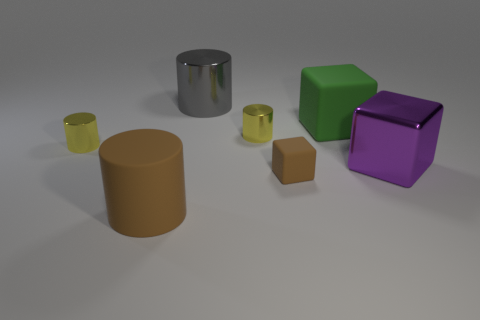Subtract all big metal blocks. How many blocks are left? 2 Add 1 yellow shiny objects. How many objects exist? 8 Subtract all purple blocks. How many yellow cylinders are left? 2 Subtract all gray cylinders. How many cylinders are left? 3 Subtract 1 cylinders. How many cylinders are left? 3 Subtract all blocks. How many objects are left? 4 Subtract all blue blocks. Subtract all red spheres. How many blocks are left? 3 Subtract all small gray shiny cylinders. Subtract all big purple things. How many objects are left? 6 Add 1 gray metal things. How many gray metal things are left? 2 Add 6 large red shiny cylinders. How many large red shiny cylinders exist? 6 